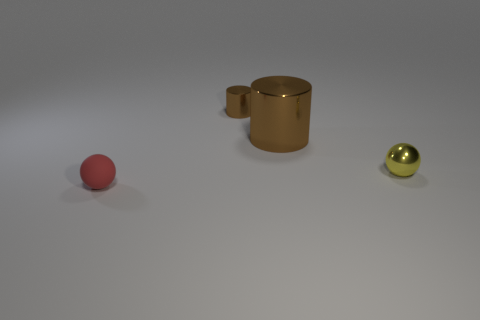Add 3 tiny red things. How many objects exist? 7 Add 3 brown shiny objects. How many brown shiny objects are left? 5 Add 2 tiny green matte cubes. How many tiny green matte cubes exist? 2 Subtract 0 green spheres. How many objects are left? 4 Subtract all small shiny cylinders. Subtract all small blue metal things. How many objects are left? 3 